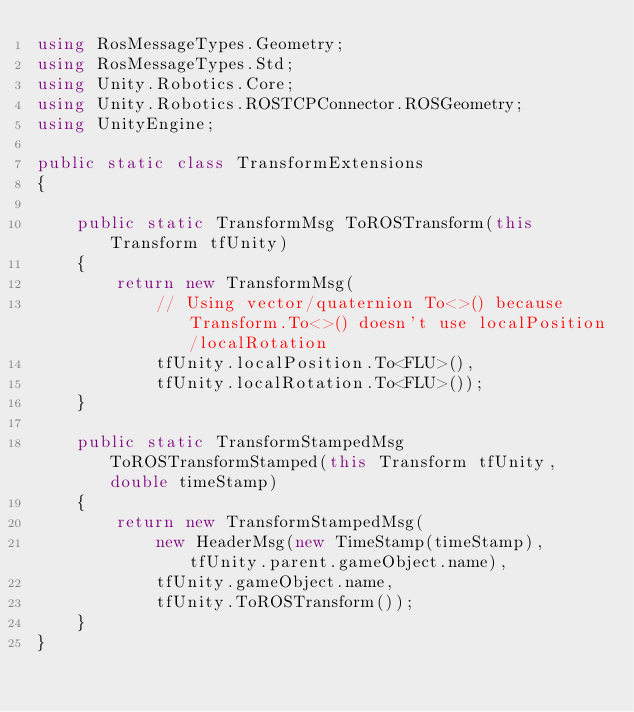Convert code to text. <code><loc_0><loc_0><loc_500><loc_500><_C#_>using RosMessageTypes.Geometry;
using RosMessageTypes.Std;
using Unity.Robotics.Core;
using Unity.Robotics.ROSTCPConnector.ROSGeometry;
using UnityEngine;

public static class TransformExtensions
{

    public static TransformMsg ToROSTransform(this Transform tfUnity)
    {
        return new TransformMsg(
            // Using vector/quaternion To<>() because Transform.To<>() doesn't use localPosition/localRotation
            tfUnity.localPosition.To<FLU>(),
            tfUnity.localRotation.To<FLU>());
    }

    public static TransformStampedMsg ToROSTransformStamped(this Transform tfUnity, double timeStamp)
    {
        return new TransformStampedMsg(
            new HeaderMsg(new TimeStamp(timeStamp), tfUnity.parent.gameObject.name),
            tfUnity.gameObject.name,
            tfUnity.ToROSTransform());
    }
}
</code> 